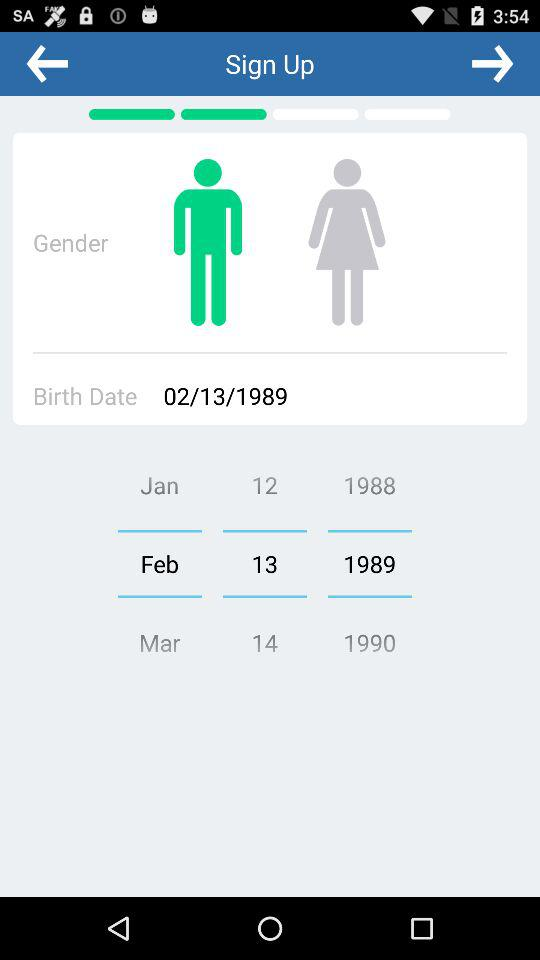What is the date of birth? The birthday is February 13, 1989. 